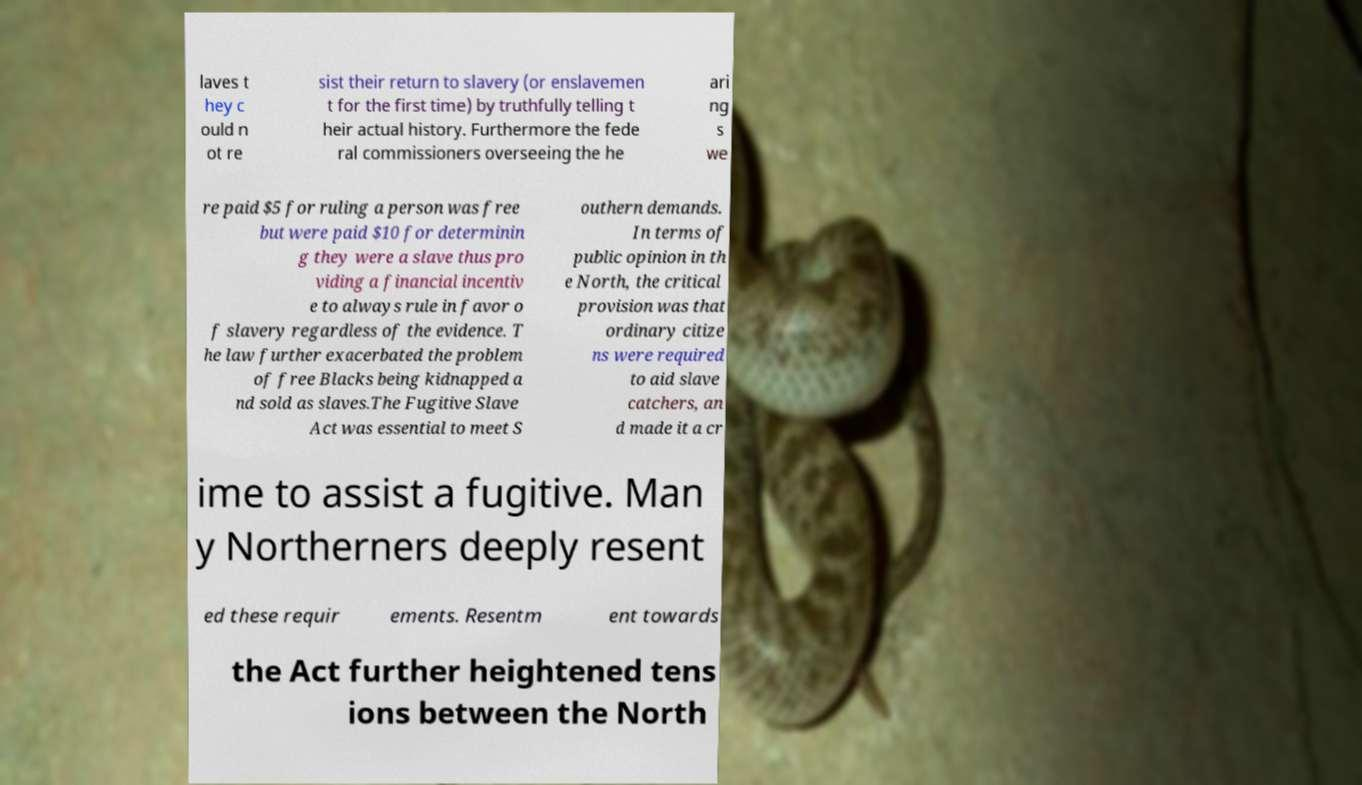For documentation purposes, I need the text within this image transcribed. Could you provide that? laves t hey c ould n ot re sist their return to slavery (or enslavemen t for the first time) by truthfully telling t heir actual history. Furthermore the fede ral commissioners overseeing the he ari ng s we re paid $5 for ruling a person was free but were paid $10 for determinin g they were a slave thus pro viding a financial incentiv e to always rule in favor o f slavery regardless of the evidence. T he law further exacerbated the problem of free Blacks being kidnapped a nd sold as slaves.The Fugitive Slave Act was essential to meet S outhern demands. In terms of public opinion in th e North, the critical provision was that ordinary citize ns were required to aid slave catchers, an d made it a cr ime to assist a fugitive. Man y Northerners deeply resent ed these requir ements. Resentm ent towards the Act further heightened tens ions between the North 